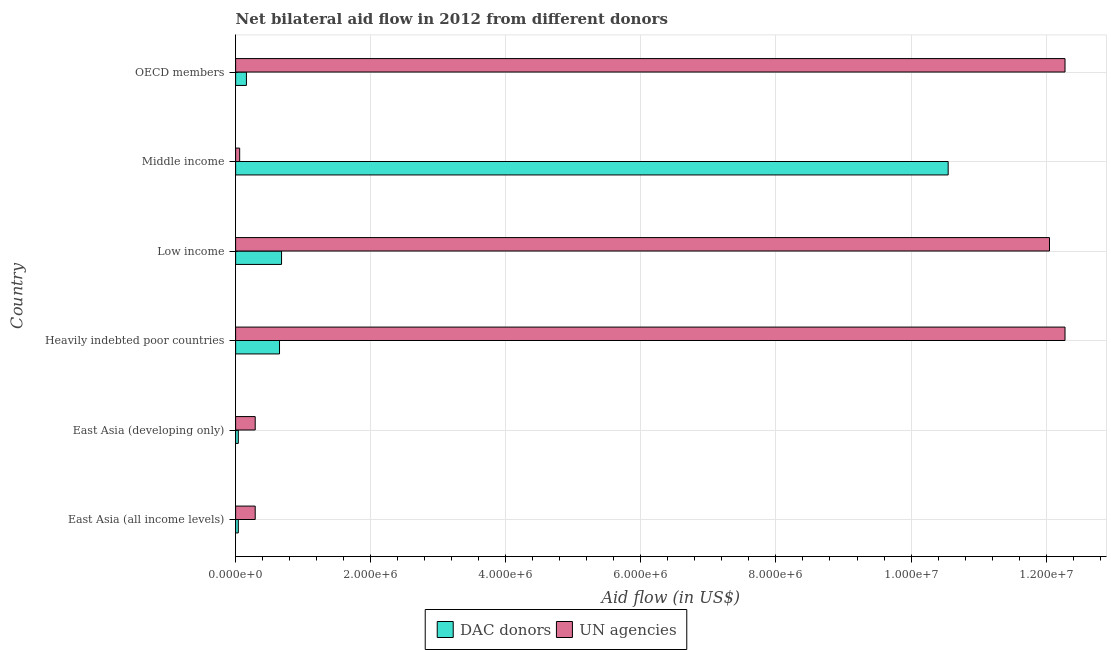How many bars are there on the 6th tick from the top?
Your response must be concise. 2. How many bars are there on the 6th tick from the bottom?
Your answer should be very brief. 2. What is the label of the 2nd group of bars from the top?
Provide a short and direct response. Middle income. In how many cases, is the number of bars for a given country not equal to the number of legend labels?
Your answer should be very brief. 0. What is the aid flow from dac donors in OECD members?
Provide a succinct answer. 1.60e+05. Across all countries, what is the maximum aid flow from dac donors?
Keep it short and to the point. 1.06e+07. Across all countries, what is the minimum aid flow from un agencies?
Provide a short and direct response. 6.00e+04. In which country was the aid flow from un agencies maximum?
Your response must be concise. Heavily indebted poor countries. In which country was the aid flow from dac donors minimum?
Your response must be concise. East Asia (all income levels). What is the total aid flow from un agencies in the graph?
Your response must be concise. 3.72e+07. What is the difference between the aid flow from un agencies in East Asia (all income levels) and that in OECD members?
Your answer should be compact. -1.20e+07. What is the difference between the aid flow from un agencies in OECD members and the aid flow from dac donors in Low income?
Your response must be concise. 1.16e+07. What is the average aid flow from un agencies per country?
Make the answer very short. 6.21e+06. What is the difference between the aid flow from dac donors and aid flow from un agencies in East Asia (all income levels)?
Offer a very short reply. -2.50e+05. What is the ratio of the aid flow from dac donors in Low income to that in Middle income?
Ensure brevity in your answer.  0.06. Is the difference between the aid flow from dac donors in East Asia (all income levels) and OECD members greater than the difference between the aid flow from un agencies in East Asia (all income levels) and OECD members?
Your response must be concise. Yes. What is the difference between the highest and the second highest aid flow from dac donors?
Your response must be concise. 9.87e+06. What is the difference between the highest and the lowest aid flow from un agencies?
Provide a short and direct response. 1.22e+07. In how many countries, is the aid flow from un agencies greater than the average aid flow from un agencies taken over all countries?
Your response must be concise. 3. Is the sum of the aid flow from un agencies in East Asia (all income levels) and East Asia (developing only) greater than the maximum aid flow from dac donors across all countries?
Make the answer very short. No. What does the 2nd bar from the top in Low income represents?
Provide a short and direct response. DAC donors. What does the 1st bar from the bottom in East Asia (developing only) represents?
Keep it short and to the point. DAC donors. Are all the bars in the graph horizontal?
Your response must be concise. Yes. How many countries are there in the graph?
Keep it short and to the point. 6. What is the difference between two consecutive major ticks on the X-axis?
Provide a short and direct response. 2.00e+06. Does the graph contain any zero values?
Offer a terse response. No. Where does the legend appear in the graph?
Make the answer very short. Bottom center. How many legend labels are there?
Provide a succinct answer. 2. How are the legend labels stacked?
Your answer should be very brief. Horizontal. What is the title of the graph?
Your response must be concise. Net bilateral aid flow in 2012 from different donors. Does "Age 65(male)" appear as one of the legend labels in the graph?
Your answer should be very brief. No. What is the label or title of the X-axis?
Give a very brief answer. Aid flow (in US$). What is the label or title of the Y-axis?
Offer a very short reply. Country. What is the Aid flow (in US$) in DAC donors in East Asia (developing only)?
Your response must be concise. 4.00e+04. What is the Aid flow (in US$) of UN agencies in East Asia (developing only)?
Ensure brevity in your answer.  2.90e+05. What is the Aid flow (in US$) of DAC donors in Heavily indebted poor countries?
Your answer should be very brief. 6.50e+05. What is the Aid flow (in US$) in UN agencies in Heavily indebted poor countries?
Provide a short and direct response. 1.23e+07. What is the Aid flow (in US$) in DAC donors in Low income?
Keep it short and to the point. 6.80e+05. What is the Aid flow (in US$) of UN agencies in Low income?
Ensure brevity in your answer.  1.20e+07. What is the Aid flow (in US$) in DAC donors in Middle income?
Offer a terse response. 1.06e+07. What is the Aid flow (in US$) in UN agencies in Middle income?
Make the answer very short. 6.00e+04. What is the Aid flow (in US$) in DAC donors in OECD members?
Offer a very short reply. 1.60e+05. What is the Aid flow (in US$) in UN agencies in OECD members?
Ensure brevity in your answer.  1.23e+07. Across all countries, what is the maximum Aid flow (in US$) in DAC donors?
Keep it short and to the point. 1.06e+07. Across all countries, what is the maximum Aid flow (in US$) in UN agencies?
Provide a short and direct response. 1.23e+07. Across all countries, what is the minimum Aid flow (in US$) of DAC donors?
Offer a terse response. 4.00e+04. What is the total Aid flow (in US$) of DAC donors in the graph?
Give a very brief answer. 1.21e+07. What is the total Aid flow (in US$) in UN agencies in the graph?
Provide a succinct answer. 3.72e+07. What is the difference between the Aid flow (in US$) in UN agencies in East Asia (all income levels) and that in East Asia (developing only)?
Your response must be concise. 0. What is the difference between the Aid flow (in US$) of DAC donors in East Asia (all income levels) and that in Heavily indebted poor countries?
Give a very brief answer. -6.10e+05. What is the difference between the Aid flow (in US$) in UN agencies in East Asia (all income levels) and that in Heavily indebted poor countries?
Give a very brief answer. -1.20e+07. What is the difference between the Aid flow (in US$) in DAC donors in East Asia (all income levels) and that in Low income?
Your response must be concise. -6.40e+05. What is the difference between the Aid flow (in US$) in UN agencies in East Asia (all income levels) and that in Low income?
Provide a short and direct response. -1.18e+07. What is the difference between the Aid flow (in US$) in DAC donors in East Asia (all income levels) and that in Middle income?
Give a very brief answer. -1.05e+07. What is the difference between the Aid flow (in US$) of UN agencies in East Asia (all income levels) and that in OECD members?
Offer a terse response. -1.20e+07. What is the difference between the Aid flow (in US$) in DAC donors in East Asia (developing only) and that in Heavily indebted poor countries?
Your answer should be very brief. -6.10e+05. What is the difference between the Aid flow (in US$) in UN agencies in East Asia (developing only) and that in Heavily indebted poor countries?
Your answer should be compact. -1.20e+07. What is the difference between the Aid flow (in US$) of DAC donors in East Asia (developing only) and that in Low income?
Provide a short and direct response. -6.40e+05. What is the difference between the Aid flow (in US$) of UN agencies in East Asia (developing only) and that in Low income?
Your answer should be compact. -1.18e+07. What is the difference between the Aid flow (in US$) in DAC donors in East Asia (developing only) and that in Middle income?
Give a very brief answer. -1.05e+07. What is the difference between the Aid flow (in US$) in UN agencies in East Asia (developing only) and that in Middle income?
Provide a short and direct response. 2.30e+05. What is the difference between the Aid flow (in US$) in UN agencies in East Asia (developing only) and that in OECD members?
Provide a short and direct response. -1.20e+07. What is the difference between the Aid flow (in US$) in DAC donors in Heavily indebted poor countries and that in Low income?
Offer a terse response. -3.00e+04. What is the difference between the Aid flow (in US$) in DAC donors in Heavily indebted poor countries and that in Middle income?
Your response must be concise. -9.90e+06. What is the difference between the Aid flow (in US$) of UN agencies in Heavily indebted poor countries and that in Middle income?
Your answer should be compact. 1.22e+07. What is the difference between the Aid flow (in US$) of UN agencies in Heavily indebted poor countries and that in OECD members?
Ensure brevity in your answer.  0. What is the difference between the Aid flow (in US$) in DAC donors in Low income and that in Middle income?
Your answer should be very brief. -9.87e+06. What is the difference between the Aid flow (in US$) of UN agencies in Low income and that in Middle income?
Ensure brevity in your answer.  1.20e+07. What is the difference between the Aid flow (in US$) of DAC donors in Low income and that in OECD members?
Provide a short and direct response. 5.20e+05. What is the difference between the Aid flow (in US$) in DAC donors in Middle income and that in OECD members?
Ensure brevity in your answer.  1.04e+07. What is the difference between the Aid flow (in US$) in UN agencies in Middle income and that in OECD members?
Your answer should be compact. -1.22e+07. What is the difference between the Aid flow (in US$) in DAC donors in East Asia (all income levels) and the Aid flow (in US$) in UN agencies in East Asia (developing only)?
Keep it short and to the point. -2.50e+05. What is the difference between the Aid flow (in US$) in DAC donors in East Asia (all income levels) and the Aid flow (in US$) in UN agencies in Heavily indebted poor countries?
Your answer should be compact. -1.22e+07. What is the difference between the Aid flow (in US$) in DAC donors in East Asia (all income levels) and the Aid flow (in US$) in UN agencies in Low income?
Provide a short and direct response. -1.20e+07. What is the difference between the Aid flow (in US$) in DAC donors in East Asia (all income levels) and the Aid flow (in US$) in UN agencies in OECD members?
Offer a terse response. -1.22e+07. What is the difference between the Aid flow (in US$) of DAC donors in East Asia (developing only) and the Aid flow (in US$) of UN agencies in Heavily indebted poor countries?
Give a very brief answer. -1.22e+07. What is the difference between the Aid flow (in US$) in DAC donors in East Asia (developing only) and the Aid flow (in US$) in UN agencies in Low income?
Offer a very short reply. -1.20e+07. What is the difference between the Aid flow (in US$) of DAC donors in East Asia (developing only) and the Aid flow (in US$) of UN agencies in Middle income?
Your answer should be very brief. -2.00e+04. What is the difference between the Aid flow (in US$) in DAC donors in East Asia (developing only) and the Aid flow (in US$) in UN agencies in OECD members?
Give a very brief answer. -1.22e+07. What is the difference between the Aid flow (in US$) in DAC donors in Heavily indebted poor countries and the Aid flow (in US$) in UN agencies in Low income?
Keep it short and to the point. -1.14e+07. What is the difference between the Aid flow (in US$) in DAC donors in Heavily indebted poor countries and the Aid flow (in US$) in UN agencies in Middle income?
Your answer should be very brief. 5.90e+05. What is the difference between the Aid flow (in US$) of DAC donors in Heavily indebted poor countries and the Aid flow (in US$) of UN agencies in OECD members?
Your answer should be compact. -1.16e+07. What is the difference between the Aid flow (in US$) of DAC donors in Low income and the Aid flow (in US$) of UN agencies in Middle income?
Your answer should be compact. 6.20e+05. What is the difference between the Aid flow (in US$) in DAC donors in Low income and the Aid flow (in US$) in UN agencies in OECD members?
Ensure brevity in your answer.  -1.16e+07. What is the difference between the Aid flow (in US$) of DAC donors in Middle income and the Aid flow (in US$) of UN agencies in OECD members?
Your answer should be compact. -1.73e+06. What is the average Aid flow (in US$) of DAC donors per country?
Your answer should be compact. 2.02e+06. What is the average Aid flow (in US$) of UN agencies per country?
Offer a terse response. 6.21e+06. What is the difference between the Aid flow (in US$) of DAC donors and Aid flow (in US$) of UN agencies in East Asia (developing only)?
Provide a succinct answer. -2.50e+05. What is the difference between the Aid flow (in US$) of DAC donors and Aid flow (in US$) of UN agencies in Heavily indebted poor countries?
Offer a very short reply. -1.16e+07. What is the difference between the Aid flow (in US$) of DAC donors and Aid flow (in US$) of UN agencies in Low income?
Provide a succinct answer. -1.14e+07. What is the difference between the Aid flow (in US$) of DAC donors and Aid flow (in US$) of UN agencies in Middle income?
Offer a terse response. 1.05e+07. What is the difference between the Aid flow (in US$) of DAC donors and Aid flow (in US$) of UN agencies in OECD members?
Ensure brevity in your answer.  -1.21e+07. What is the ratio of the Aid flow (in US$) of DAC donors in East Asia (all income levels) to that in Heavily indebted poor countries?
Make the answer very short. 0.06. What is the ratio of the Aid flow (in US$) of UN agencies in East Asia (all income levels) to that in Heavily indebted poor countries?
Ensure brevity in your answer.  0.02. What is the ratio of the Aid flow (in US$) of DAC donors in East Asia (all income levels) to that in Low income?
Make the answer very short. 0.06. What is the ratio of the Aid flow (in US$) of UN agencies in East Asia (all income levels) to that in Low income?
Your answer should be very brief. 0.02. What is the ratio of the Aid flow (in US$) in DAC donors in East Asia (all income levels) to that in Middle income?
Make the answer very short. 0. What is the ratio of the Aid flow (in US$) in UN agencies in East Asia (all income levels) to that in Middle income?
Offer a terse response. 4.83. What is the ratio of the Aid flow (in US$) in UN agencies in East Asia (all income levels) to that in OECD members?
Provide a short and direct response. 0.02. What is the ratio of the Aid flow (in US$) in DAC donors in East Asia (developing only) to that in Heavily indebted poor countries?
Provide a short and direct response. 0.06. What is the ratio of the Aid flow (in US$) in UN agencies in East Asia (developing only) to that in Heavily indebted poor countries?
Give a very brief answer. 0.02. What is the ratio of the Aid flow (in US$) in DAC donors in East Asia (developing only) to that in Low income?
Keep it short and to the point. 0.06. What is the ratio of the Aid flow (in US$) in UN agencies in East Asia (developing only) to that in Low income?
Make the answer very short. 0.02. What is the ratio of the Aid flow (in US$) of DAC donors in East Asia (developing only) to that in Middle income?
Offer a terse response. 0. What is the ratio of the Aid flow (in US$) in UN agencies in East Asia (developing only) to that in Middle income?
Offer a terse response. 4.83. What is the ratio of the Aid flow (in US$) of DAC donors in East Asia (developing only) to that in OECD members?
Offer a very short reply. 0.25. What is the ratio of the Aid flow (in US$) in UN agencies in East Asia (developing only) to that in OECD members?
Your answer should be very brief. 0.02. What is the ratio of the Aid flow (in US$) in DAC donors in Heavily indebted poor countries to that in Low income?
Provide a short and direct response. 0.96. What is the ratio of the Aid flow (in US$) of UN agencies in Heavily indebted poor countries to that in Low income?
Give a very brief answer. 1.02. What is the ratio of the Aid flow (in US$) in DAC donors in Heavily indebted poor countries to that in Middle income?
Keep it short and to the point. 0.06. What is the ratio of the Aid flow (in US$) in UN agencies in Heavily indebted poor countries to that in Middle income?
Your answer should be very brief. 204.67. What is the ratio of the Aid flow (in US$) of DAC donors in Heavily indebted poor countries to that in OECD members?
Your answer should be very brief. 4.06. What is the ratio of the Aid flow (in US$) of UN agencies in Heavily indebted poor countries to that in OECD members?
Offer a terse response. 1. What is the ratio of the Aid flow (in US$) in DAC donors in Low income to that in Middle income?
Provide a succinct answer. 0.06. What is the ratio of the Aid flow (in US$) of UN agencies in Low income to that in Middle income?
Give a very brief answer. 200.83. What is the ratio of the Aid flow (in US$) in DAC donors in Low income to that in OECD members?
Your answer should be compact. 4.25. What is the ratio of the Aid flow (in US$) in UN agencies in Low income to that in OECD members?
Your answer should be very brief. 0.98. What is the ratio of the Aid flow (in US$) of DAC donors in Middle income to that in OECD members?
Provide a succinct answer. 65.94. What is the ratio of the Aid flow (in US$) in UN agencies in Middle income to that in OECD members?
Your response must be concise. 0. What is the difference between the highest and the second highest Aid flow (in US$) in DAC donors?
Keep it short and to the point. 9.87e+06. What is the difference between the highest and the lowest Aid flow (in US$) of DAC donors?
Keep it short and to the point. 1.05e+07. What is the difference between the highest and the lowest Aid flow (in US$) in UN agencies?
Your answer should be compact. 1.22e+07. 